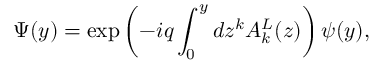Convert formula to latex. <formula><loc_0><loc_0><loc_500><loc_500>\Psi ( y ) = \exp \left ( { - i q \int _ { 0 } ^ { y } { d z ^ { k } A _ { k } ^ { L } ( z ) } } \right ) \psi ( y ) ,</formula> 